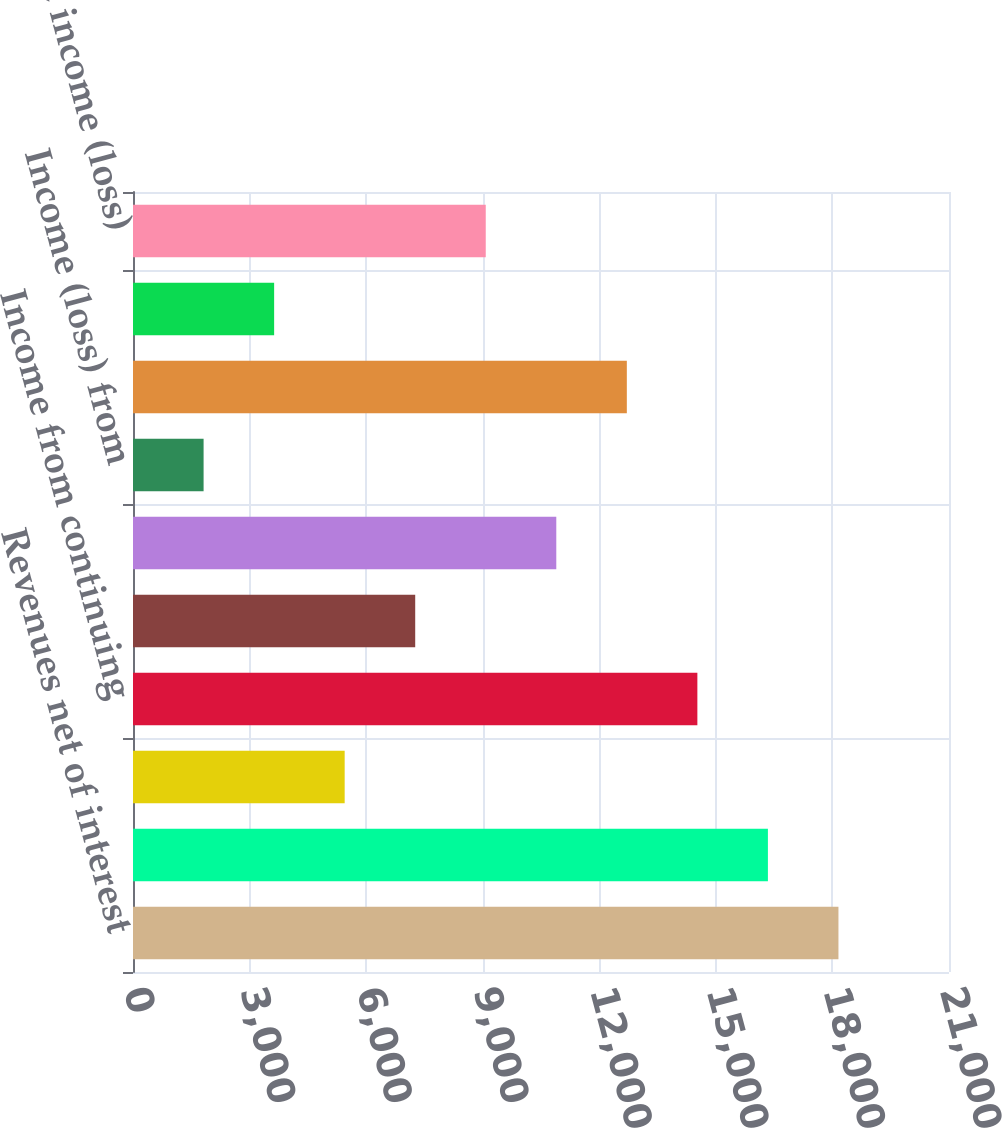<chart> <loc_0><loc_0><loc_500><loc_500><bar_chart><fcel>Revenues net of interest<fcel>Operating expenses<fcel>Provisions for credit losses<fcel>Income from continuing<fcel>Income taxes<fcel>Income (loss) from continuing<fcel>Income (loss) from<fcel>Net income before attribution<fcel>Noncontrolling interests<fcel>Citigroup's net income (loss)<nl><fcel>18155<fcel>16339.6<fcel>5447.39<fcel>14524.2<fcel>7262.76<fcel>10893.5<fcel>1816.65<fcel>12708.9<fcel>3632.02<fcel>9078.13<nl></chart> 